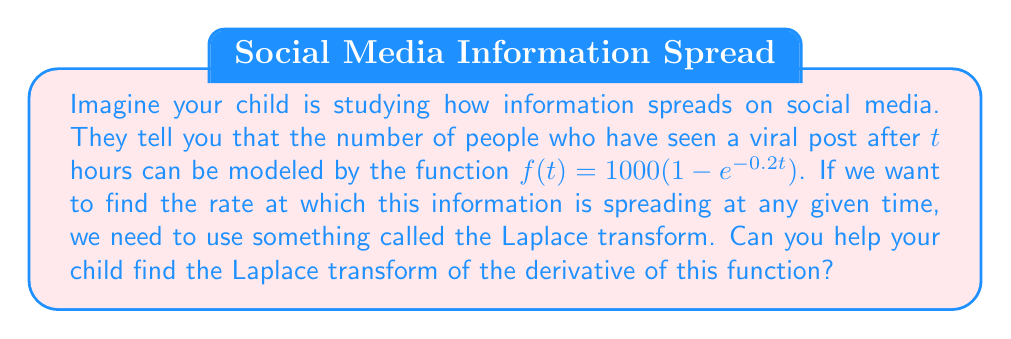Help me with this question. Let's break this down step-by-step:

1) First, we need to find the derivative of $f(t)$. Using the chain rule:

   $$f'(t) = 1000 \cdot 0.2e^{-0.2t} = 200e^{-0.2t}$$

2) Now, we need to find the Laplace transform of $f'(t)$. The Laplace transform is defined as:

   $$\mathcal{L}\{f(t)\} = F(s) = \int_0^\infty e^{-st}f(t)dt$$

3) So, we need to calculate:

   $$\mathcal{L}\{f'(t)\} = \int_0^\infty e^{-st}(200e^{-0.2t})dt$$

4) We can simplify this:

   $$= 200\int_0^\infty e^{-(s+0.2)t}dt$$

5) This integral is of the form $\int_0^\infty e^{-at}dt = \frac{1}{a}$, where $a = s+0.2$. So:

   $$= 200 \cdot \frac{1}{s+0.2} = \frac{200}{s+0.2}$$

6) Therefore, the Laplace transform of $f'(t)$ is $\frac{200}{s+0.2}$.
Answer: $$\mathcal{L}\{f'(t)\} = \frac{200}{s+0.2}$$ 